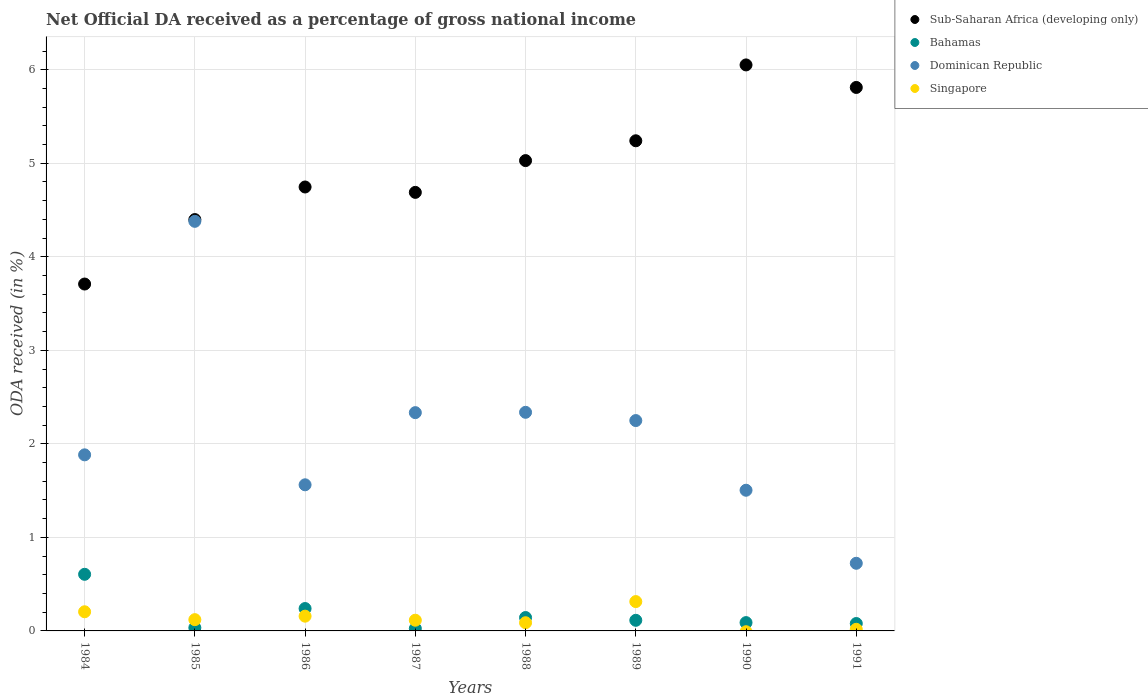How many different coloured dotlines are there?
Your response must be concise. 4. Is the number of dotlines equal to the number of legend labels?
Keep it short and to the point. No. What is the net official DA received in Bahamas in 1984?
Your response must be concise. 0.61. Across all years, what is the maximum net official DA received in Dominican Republic?
Provide a succinct answer. 4.38. Across all years, what is the minimum net official DA received in Bahamas?
Give a very brief answer. 0.03. What is the total net official DA received in Singapore in the graph?
Provide a short and direct response. 1.02. What is the difference between the net official DA received in Dominican Republic in 1987 and that in 1988?
Ensure brevity in your answer.  -0. What is the difference between the net official DA received in Singapore in 1984 and the net official DA received in Dominican Republic in 1989?
Provide a succinct answer. -2.04. What is the average net official DA received in Sub-Saharan Africa (developing only) per year?
Make the answer very short. 4.96. In the year 1988, what is the difference between the net official DA received in Bahamas and net official DA received in Dominican Republic?
Offer a very short reply. -2.19. What is the ratio of the net official DA received in Bahamas in 1986 to that in 1990?
Your answer should be compact. 2.69. Is the difference between the net official DA received in Bahamas in 1985 and 1991 greater than the difference between the net official DA received in Dominican Republic in 1985 and 1991?
Provide a succinct answer. No. What is the difference between the highest and the second highest net official DA received in Singapore?
Provide a succinct answer. 0.11. What is the difference between the highest and the lowest net official DA received in Bahamas?
Provide a succinct answer. 0.58. In how many years, is the net official DA received in Dominican Republic greater than the average net official DA received in Dominican Republic taken over all years?
Provide a short and direct response. 4. Is the sum of the net official DA received in Singapore in 1984 and 1988 greater than the maximum net official DA received in Sub-Saharan Africa (developing only) across all years?
Offer a terse response. No. Does the net official DA received in Sub-Saharan Africa (developing only) monotonically increase over the years?
Offer a terse response. No. Is the net official DA received in Sub-Saharan Africa (developing only) strictly less than the net official DA received in Dominican Republic over the years?
Keep it short and to the point. No. How many years are there in the graph?
Your answer should be very brief. 8. What is the difference between two consecutive major ticks on the Y-axis?
Your response must be concise. 1. Does the graph contain any zero values?
Make the answer very short. Yes. How many legend labels are there?
Provide a short and direct response. 4. How are the legend labels stacked?
Ensure brevity in your answer.  Vertical. What is the title of the graph?
Your answer should be very brief. Net Official DA received as a percentage of gross national income. What is the label or title of the Y-axis?
Keep it short and to the point. ODA received (in %). What is the ODA received (in %) in Sub-Saharan Africa (developing only) in 1984?
Ensure brevity in your answer.  3.71. What is the ODA received (in %) in Bahamas in 1984?
Your response must be concise. 0.61. What is the ODA received (in %) of Dominican Republic in 1984?
Your response must be concise. 1.88. What is the ODA received (in %) of Singapore in 1984?
Make the answer very short. 0.2. What is the ODA received (in %) of Sub-Saharan Africa (developing only) in 1985?
Your response must be concise. 4.4. What is the ODA received (in %) in Bahamas in 1985?
Keep it short and to the point. 0.03. What is the ODA received (in %) in Dominican Republic in 1985?
Make the answer very short. 4.38. What is the ODA received (in %) of Singapore in 1985?
Provide a short and direct response. 0.12. What is the ODA received (in %) of Sub-Saharan Africa (developing only) in 1986?
Make the answer very short. 4.75. What is the ODA received (in %) in Bahamas in 1986?
Your response must be concise. 0.24. What is the ODA received (in %) of Dominican Republic in 1986?
Offer a very short reply. 1.56. What is the ODA received (in %) of Singapore in 1986?
Ensure brevity in your answer.  0.16. What is the ODA received (in %) in Sub-Saharan Africa (developing only) in 1987?
Ensure brevity in your answer.  4.69. What is the ODA received (in %) of Bahamas in 1987?
Your answer should be compact. 0.03. What is the ODA received (in %) in Dominican Republic in 1987?
Make the answer very short. 2.33. What is the ODA received (in %) in Singapore in 1987?
Provide a succinct answer. 0.11. What is the ODA received (in %) in Sub-Saharan Africa (developing only) in 1988?
Your response must be concise. 5.03. What is the ODA received (in %) of Bahamas in 1988?
Provide a short and direct response. 0.14. What is the ODA received (in %) in Dominican Republic in 1988?
Keep it short and to the point. 2.34. What is the ODA received (in %) of Singapore in 1988?
Provide a short and direct response. 0.09. What is the ODA received (in %) of Sub-Saharan Africa (developing only) in 1989?
Ensure brevity in your answer.  5.24. What is the ODA received (in %) in Bahamas in 1989?
Your answer should be compact. 0.11. What is the ODA received (in %) in Dominican Republic in 1989?
Provide a short and direct response. 2.25. What is the ODA received (in %) of Singapore in 1989?
Make the answer very short. 0.31. What is the ODA received (in %) of Sub-Saharan Africa (developing only) in 1990?
Make the answer very short. 6.05. What is the ODA received (in %) in Bahamas in 1990?
Make the answer very short. 0.09. What is the ODA received (in %) of Dominican Republic in 1990?
Make the answer very short. 1.5. What is the ODA received (in %) in Sub-Saharan Africa (developing only) in 1991?
Make the answer very short. 5.81. What is the ODA received (in %) in Bahamas in 1991?
Offer a very short reply. 0.08. What is the ODA received (in %) in Dominican Republic in 1991?
Provide a succinct answer. 0.72. What is the ODA received (in %) of Singapore in 1991?
Provide a short and direct response. 0.02. Across all years, what is the maximum ODA received (in %) in Sub-Saharan Africa (developing only)?
Offer a very short reply. 6.05. Across all years, what is the maximum ODA received (in %) of Bahamas?
Offer a terse response. 0.61. Across all years, what is the maximum ODA received (in %) in Dominican Republic?
Give a very brief answer. 4.38. Across all years, what is the maximum ODA received (in %) in Singapore?
Offer a very short reply. 0.31. Across all years, what is the minimum ODA received (in %) in Sub-Saharan Africa (developing only)?
Ensure brevity in your answer.  3.71. Across all years, what is the minimum ODA received (in %) in Bahamas?
Your response must be concise. 0.03. Across all years, what is the minimum ODA received (in %) in Dominican Republic?
Your answer should be very brief. 0.72. Across all years, what is the minimum ODA received (in %) in Singapore?
Ensure brevity in your answer.  0. What is the total ODA received (in %) of Sub-Saharan Africa (developing only) in the graph?
Your response must be concise. 39.67. What is the total ODA received (in %) of Bahamas in the graph?
Offer a terse response. 1.33. What is the total ODA received (in %) in Dominican Republic in the graph?
Your answer should be very brief. 16.97. What is the total ODA received (in %) of Singapore in the graph?
Offer a terse response. 1.02. What is the difference between the ODA received (in %) of Sub-Saharan Africa (developing only) in 1984 and that in 1985?
Make the answer very short. -0.69. What is the difference between the ODA received (in %) in Bahamas in 1984 and that in 1985?
Your response must be concise. 0.57. What is the difference between the ODA received (in %) in Dominican Republic in 1984 and that in 1985?
Offer a very short reply. -2.5. What is the difference between the ODA received (in %) of Singapore in 1984 and that in 1985?
Make the answer very short. 0.08. What is the difference between the ODA received (in %) in Sub-Saharan Africa (developing only) in 1984 and that in 1986?
Offer a very short reply. -1.04. What is the difference between the ODA received (in %) of Bahamas in 1984 and that in 1986?
Your answer should be compact. 0.37. What is the difference between the ODA received (in %) in Dominican Republic in 1984 and that in 1986?
Your response must be concise. 0.32. What is the difference between the ODA received (in %) in Singapore in 1984 and that in 1986?
Provide a short and direct response. 0.05. What is the difference between the ODA received (in %) in Sub-Saharan Africa (developing only) in 1984 and that in 1987?
Provide a short and direct response. -0.98. What is the difference between the ODA received (in %) in Bahamas in 1984 and that in 1987?
Your answer should be compact. 0.58. What is the difference between the ODA received (in %) of Dominican Republic in 1984 and that in 1987?
Your answer should be very brief. -0.45. What is the difference between the ODA received (in %) of Singapore in 1984 and that in 1987?
Provide a short and direct response. 0.09. What is the difference between the ODA received (in %) in Sub-Saharan Africa (developing only) in 1984 and that in 1988?
Your answer should be very brief. -1.32. What is the difference between the ODA received (in %) of Bahamas in 1984 and that in 1988?
Ensure brevity in your answer.  0.46. What is the difference between the ODA received (in %) of Dominican Republic in 1984 and that in 1988?
Keep it short and to the point. -0.45. What is the difference between the ODA received (in %) in Singapore in 1984 and that in 1988?
Your response must be concise. 0.12. What is the difference between the ODA received (in %) of Sub-Saharan Africa (developing only) in 1984 and that in 1989?
Offer a terse response. -1.53. What is the difference between the ODA received (in %) of Bahamas in 1984 and that in 1989?
Ensure brevity in your answer.  0.49. What is the difference between the ODA received (in %) in Dominican Republic in 1984 and that in 1989?
Give a very brief answer. -0.37. What is the difference between the ODA received (in %) of Singapore in 1984 and that in 1989?
Offer a terse response. -0.11. What is the difference between the ODA received (in %) of Sub-Saharan Africa (developing only) in 1984 and that in 1990?
Ensure brevity in your answer.  -2.34. What is the difference between the ODA received (in %) of Bahamas in 1984 and that in 1990?
Provide a short and direct response. 0.52. What is the difference between the ODA received (in %) of Dominican Republic in 1984 and that in 1990?
Your answer should be very brief. 0.38. What is the difference between the ODA received (in %) in Sub-Saharan Africa (developing only) in 1984 and that in 1991?
Your response must be concise. -2.1. What is the difference between the ODA received (in %) of Bahamas in 1984 and that in 1991?
Your response must be concise. 0.53. What is the difference between the ODA received (in %) of Dominican Republic in 1984 and that in 1991?
Ensure brevity in your answer.  1.16. What is the difference between the ODA received (in %) of Singapore in 1984 and that in 1991?
Provide a succinct answer. 0.19. What is the difference between the ODA received (in %) of Sub-Saharan Africa (developing only) in 1985 and that in 1986?
Keep it short and to the point. -0.35. What is the difference between the ODA received (in %) in Bahamas in 1985 and that in 1986?
Make the answer very short. -0.21. What is the difference between the ODA received (in %) in Dominican Republic in 1985 and that in 1986?
Your response must be concise. 2.82. What is the difference between the ODA received (in %) of Singapore in 1985 and that in 1986?
Give a very brief answer. -0.04. What is the difference between the ODA received (in %) in Sub-Saharan Africa (developing only) in 1985 and that in 1987?
Provide a succinct answer. -0.29. What is the difference between the ODA received (in %) in Bahamas in 1985 and that in 1987?
Provide a short and direct response. 0.01. What is the difference between the ODA received (in %) of Dominican Republic in 1985 and that in 1987?
Your answer should be very brief. 2.05. What is the difference between the ODA received (in %) of Singapore in 1985 and that in 1987?
Offer a terse response. 0.01. What is the difference between the ODA received (in %) of Sub-Saharan Africa (developing only) in 1985 and that in 1988?
Give a very brief answer. -0.63. What is the difference between the ODA received (in %) in Bahamas in 1985 and that in 1988?
Your response must be concise. -0.11. What is the difference between the ODA received (in %) of Dominican Republic in 1985 and that in 1988?
Provide a succinct answer. 2.04. What is the difference between the ODA received (in %) of Singapore in 1985 and that in 1988?
Your answer should be compact. 0.03. What is the difference between the ODA received (in %) in Sub-Saharan Africa (developing only) in 1985 and that in 1989?
Ensure brevity in your answer.  -0.84. What is the difference between the ODA received (in %) in Bahamas in 1985 and that in 1989?
Give a very brief answer. -0.08. What is the difference between the ODA received (in %) in Dominican Republic in 1985 and that in 1989?
Make the answer very short. 2.13. What is the difference between the ODA received (in %) of Singapore in 1985 and that in 1989?
Ensure brevity in your answer.  -0.19. What is the difference between the ODA received (in %) of Sub-Saharan Africa (developing only) in 1985 and that in 1990?
Your response must be concise. -1.65. What is the difference between the ODA received (in %) of Bahamas in 1985 and that in 1990?
Keep it short and to the point. -0.06. What is the difference between the ODA received (in %) in Dominican Republic in 1985 and that in 1990?
Give a very brief answer. 2.87. What is the difference between the ODA received (in %) in Sub-Saharan Africa (developing only) in 1985 and that in 1991?
Your response must be concise. -1.41. What is the difference between the ODA received (in %) in Bahamas in 1985 and that in 1991?
Offer a very short reply. -0.05. What is the difference between the ODA received (in %) of Dominican Republic in 1985 and that in 1991?
Keep it short and to the point. 3.66. What is the difference between the ODA received (in %) in Singapore in 1985 and that in 1991?
Your response must be concise. 0.1. What is the difference between the ODA received (in %) in Sub-Saharan Africa (developing only) in 1986 and that in 1987?
Offer a terse response. 0.06. What is the difference between the ODA received (in %) in Bahamas in 1986 and that in 1987?
Your response must be concise. 0.21. What is the difference between the ODA received (in %) of Dominican Republic in 1986 and that in 1987?
Offer a very short reply. -0.77. What is the difference between the ODA received (in %) in Singapore in 1986 and that in 1987?
Provide a succinct answer. 0.04. What is the difference between the ODA received (in %) of Sub-Saharan Africa (developing only) in 1986 and that in 1988?
Provide a short and direct response. -0.28. What is the difference between the ODA received (in %) of Bahamas in 1986 and that in 1988?
Keep it short and to the point. 0.1. What is the difference between the ODA received (in %) in Dominican Republic in 1986 and that in 1988?
Provide a short and direct response. -0.78. What is the difference between the ODA received (in %) in Singapore in 1986 and that in 1988?
Ensure brevity in your answer.  0.07. What is the difference between the ODA received (in %) of Sub-Saharan Africa (developing only) in 1986 and that in 1989?
Your answer should be compact. -0.49. What is the difference between the ODA received (in %) in Bahamas in 1986 and that in 1989?
Provide a succinct answer. 0.13. What is the difference between the ODA received (in %) in Dominican Republic in 1986 and that in 1989?
Provide a succinct answer. -0.69. What is the difference between the ODA received (in %) in Singapore in 1986 and that in 1989?
Your answer should be very brief. -0.16. What is the difference between the ODA received (in %) in Sub-Saharan Africa (developing only) in 1986 and that in 1990?
Make the answer very short. -1.31. What is the difference between the ODA received (in %) in Bahamas in 1986 and that in 1990?
Ensure brevity in your answer.  0.15. What is the difference between the ODA received (in %) in Dominican Republic in 1986 and that in 1990?
Ensure brevity in your answer.  0.06. What is the difference between the ODA received (in %) in Sub-Saharan Africa (developing only) in 1986 and that in 1991?
Your answer should be very brief. -1.06. What is the difference between the ODA received (in %) of Bahamas in 1986 and that in 1991?
Provide a succinct answer. 0.16. What is the difference between the ODA received (in %) of Dominican Republic in 1986 and that in 1991?
Make the answer very short. 0.84. What is the difference between the ODA received (in %) of Singapore in 1986 and that in 1991?
Keep it short and to the point. 0.14. What is the difference between the ODA received (in %) in Sub-Saharan Africa (developing only) in 1987 and that in 1988?
Provide a short and direct response. -0.34. What is the difference between the ODA received (in %) of Bahamas in 1987 and that in 1988?
Your answer should be compact. -0.12. What is the difference between the ODA received (in %) in Dominican Republic in 1987 and that in 1988?
Keep it short and to the point. -0. What is the difference between the ODA received (in %) in Singapore in 1987 and that in 1988?
Give a very brief answer. 0.03. What is the difference between the ODA received (in %) in Sub-Saharan Africa (developing only) in 1987 and that in 1989?
Your answer should be compact. -0.55. What is the difference between the ODA received (in %) of Bahamas in 1987 and that in 1989?
Ensure brevity in your answer.  -0.09. What is the difference between the ODA received (in %) of Dominican Republic in 1987 and that in 1989?
Your answer should be compact. 0.08. What is the difference between the ODA received (in %) in Singapore in 1987 and that in 1989?
Your response must be concise. -0.2. What is the difference between the ODA received (in %) of Sub-Saharan Africa (developing only) in 1987 and that in 1990?
Your answer should be compact. -1.36. What is the difference between the ODA received (in %) of Bahamas in 1987 and that in 1990?
Provide a short and direct response. -0.06. What is the difference between the ODA received (in %) of Dominican Republic in 1987 and that in 1990?
Give a very brief answer. 0.83. What is the difference between the ODA received (in %) of Sub-Saharan Africa (developing only) in 1987 and that in 1991?
Keep it short and to the point. -1.12. What is the difference between the ODA received (in %) of Bahamas in 1987 and that in 1991?
Your response must be concise. -0.05. What is the difference between the ODA received (in %) in Dominican Republic in 1987 and that in 1991?
Your answer should be compact. 1.61. What is the difference between the ODA received (in %) of Singapore in 1987 and that in 1991?
Offer a terse response. 0.1. What is the difference between the ODA received (in %) in Sub-Saharan Africa (developing only) in 1988 and that in 1989?
Keep it short and to the point. -0.21. What is the difference between the ODA received (in %) of Bahamas in 1988 and that in 1989?
Offer a very short reply. 0.03. What is the difference between the ODA received (in %) of Dominican Republic in 1988 and that in 1989?
Offer a terse response. 0.09. What is the difference between the ODA received (in %) in Singapore in 1988 and that in 1989?
Provide a short and direct response. -0.23. What is the difference between the ODA received (in %) of Sub-Saharan Africa (developing only) in 1988 and that in 1990?
Your answer should be compact. -1.02. What is the difference between the ODA received (in %) of Bahamas in 1988 and that in 1990?
Your response must be concise. 0.05. What is the difference between the ODA received (in %) in Dominican Republic in 1988 and that in 1990?
Keep it short and to the point. 0.83. What is the difference between the ODA received (in %) of Sub-Saharan Africa (developing only) in 1988 and that in 1991?
Your response must be concise. -0.78. What is the difference between the ODA received (in %) in Bahamas in 1988 and that in 1991?
Give a very brief answer. 0.06. What is the difference between the ODA received (in %) in Dominican Republic in 1988 and that in 1991?
Provide a succinct answer. 1.61. What is the difference between the ODA received (in %) of Singapore in 1988 and that in 1991?
Your answer should be very brief. 0.07. What is the difference between the ODA received (in %) in Sub-Saharan Africa (developing only) in 1989 and that in 1990?
Give a very brief answer. -0.81. What is the difference between the ODA received (in %) of Bahamas in 1989 and that in 1990?
Provide a succinct answer. 0.02. What is the difference between the ODA received (in %) in Dominican Republic in 1989 and that in 1990?
Offer a terse response. 0.74. What is the difference between the ODA received (in %) of Sub-Saharan Africa (developing only) in 1989 and that in 1991?
Give a very brief answer. -0.57. What is the difference between the ODA received (in %) in Bahamas in 1989 and that in 1991?
Give a very brief answer. 0.03. What is the difference between the ODA received (in %) of Dominican Republic in 1989 and that in 1991?
Offer a very short reply. 1.53. What is the difference between the ODA received (in %) of Singapore in 1989 and that in 1991?
Your response must be concise. 0.3. What is the difference between the ODA received (in %) in Sub-Saharan Africa (developing only) in 1990 and that in 1991?
Offer a terse response. 0.24. What is the difference between the ODA received (in %) of Bahamas in 1990 and that in 1991?
Provide a succinct answer. 0.01. What is the difference between the ODA received (in %) in Dominican Republic in 1990 and that in 1991?
Ensure brevity in your answer.  0.78. What is the difference between the ODA received (in %) of Sub-Saharan Africa (developing only) in 1984 and the ODA received (in %) of Bahamas in 1985?
Provide a short and direct response. 3.67. What is the difference between the ODA received (in %) in Sub-Saharan Africa (developing only) in 1984 and the ODA received (in %) in Dominican Republic in 1985?
Keep it short and to the point. -0.67. What is the difference between the ODA received (in %) in Sub-Saharan Africa (developing only) in 1984 and the ODA received (in %) in Singapore in 1985?
Provide a short and direct response. 3.59. What is the difference between the ODA received (in %) of Bahamas in 1984 and the ODA received (in %) of Dominican Republic in 1985?
Keep it short and to the point. -3.77. What is the difference between the ODA received (in %) of Bahamas in 1984 and the ODA received (in %) of Singapore in 1985?
Ensure brevity in your answer.  0.48. What is the difference between the ODA received (in %) of Dominican Republic in 1984 and the ODA received (in %) of Singapore in 1985?
Your answer should be compact. 1.76. What is the difference between the ODA received (in %) in Sub-Saharan Africa (developing only) in 1984 and the ODA received (in %) in Bahamas in 1986?
Ensure brevity in your answer.  3.47. What is the difference between the ODA received (in %) of Sub-Saharan Africa (developing only) in 1984 and the ODA received (in %) of Dominican Republic in 1986?
Offer a terse response. 2.15. What is the difference between the ODA received (in %) of Sub-Saharan Africa (developing only) in 1984 and the ODA received (in %) of Singapore in 1986?
Keep it short and to the point. 3.55. What is the difference between the ODA received (in %) in Bahamas in 1984 and the ODA received (in %) in Dominican Republic in 1986?
Make the answer very short. -0.96. What is the difference between the ODA received (in %) in Bahamas in 1984 and the ODA received (in %) in Singapore in 1986?
Provide a succinct answer. 0.45. What is the difference between the ODA received (in %) of Dominican Republic in 1984 and the ODA received (in %) of Singapore in 1986?
Your answer should be very brief. 1.72. What is the difference between the ODA received (in %) of Sub-Saharan Africa (developing only) in 1984 and the ODA received (in %) of Bahamas in 1987?
Your answer should be compact. 3.68. What is the difference between the ODA received (in %) in Sub-Saharan Africa (developing only) in 1984 and the ODA received (in %) in Dominican Republic in 1987?
Offer a terse response. 1.38. What is the difference between the ODA received (in %) of Sub-Saharan Africa (developing only) in 1984 and the ODA received (in %) of Singapore in 1987?
Keep it short and to the point. 3.59. What is the difference between the ODA received (in %) of Bahamas in 1984 and the ODA received (in %) of Dominican Republic in 1987?
Make the answer very short. -1.73. What is the difference between the ODA received (in %) in Bahamas in 1984 and the ODA received (in %) in Singapore in 1987?
Provide a succinct answer. 0.49. What is the difference between the ODA received (in %) of Dominican Republic in 1984 and the ODA received (in %) of Singapore in 1987?
Your response must be concise. 1.77. What is the difference between the ODA received (in %) in Sub-Saharan Africa (developing only) in 1984 and the ODA received (in %) in Bahamas in 1988?
Your response must be concise. 3.57. What is the difference between the ODA received (in %) in Sub-Saharan Africa (developing only) in 1984 and the ODA received (in %) in Dominican Republic in 1988?
Your answer should be very brief. 1.37. What is the difference between the ODA received (in %) of Sub-Saharan Africa (developing only) in 1984 and the ODA received (in %) of Singapore in 1988?
Offer a terse response. 3.62. What is the difference between the ODA received (in %) in Bahamas in 1984 and the ODA received (in %) in Dominican Republic in 1988?
Make the answer very short. -1.73. What is the difference between the ODA received (in %) in Bahamas in 1984 and the ODA received (in %) in Singapore in 1988?
Your answer should be compact. 0.52. What is the difference between the ODA received (in %) in Dominican Republic in 1984 and the ODA received (in %) in Singapore in 1988?
Provide a short and direct response. 1.79. What is the difference between the ODA received (in %) in Sub-Saharan Africa (developing only) in 1984 and the ODA received (in %) in Bahamas in 1989?
Your answer should be very brief. 3.6. What is the difference between the ODA received (in %) in Sub-Saharan Africa (developing only) in 1984 and the ODA received (in %) in Dominican Republic in 1989?
Offer a terse response. 1.46. What is the difference between the ODA received (in %) of Sub-Saharan Africa (developing only) in 1984 and the ODA received (in %) of Singapore in 1989?
Provide a succinct answer. 3.4. What is the difference between the ODA received (in %) of Bahamas in 1984 and the ODA received (in %) of Dominican Republic in 1989?
Ensure brevity in your answer.  -1.64. What is the difference between the ODA received (in %) of Bahamas in 1984 and the ODA received (in %) of Singapore in 1989?
Provide a succinct answer. 0.29. What is the difference between the ODA received (in %) in Dominican Republic in 1984 and the ODA received (in %) in Singapore in 1989?
Your answer should be compact. 1.57. What is the difference between the ODA received (in %) in Sub-Saharan Africa (developing only) in 1984 and the ODA received (in %) in Bahamas in 1990?
Give a very brief answer. 3.62. What is the difference between the ODA received (in %) of Sub-Saharan Africa (developing only) in 1984 and the ODA received (in %) of Dominican Republic in 1990?
Provide a short and direct response. 2.2. What is the difference between the ODA received (in %) in Bahamas in 1984 and the ODA received (in %) in Dominican Republic in 1990?
Provide a short and direct response. -0.9. What is the difference between the ODA received (in %) in Sub-Saharan Africa (developing only) in 1984 and the ODA received (in %) in Bahamas in 1991?
Give a very brief answer. 3.63. What is the difference between the ODA received (in %) in Sub-Saharan Africa (developing only) in 1984 and the ODA received (in %) in Dominican Republic in 1991?
Offer a terse response. 2.99. What is the difference between the ODA received (in %) of Sub-Saharan Africa (developing only) in 1984 and the ODA received (in %) of Singapore in 1991?
Keep it short and to the point. 3.69. What is the difference between the ODA received (in %) of Bahamas in 1984 and the ODA received (in %) of Dominican Republic in 1991?
Your answer should be compact. -0.12. What is the difference between the ODA received (in %) in Bahamas in 1984 and the ODA received (in %) in Singapore in 1991?
Provide a short and direct response. 0.59. What is the difference between the ODA received (in %) of Dominican Republic in 1984 and the ODA received (in %) of Singapore in 1991?
Offer a terse response. 1.87. What is the difference between the ODA received (in %) of Sub-Saharan Africa (developing only) in 1985 and the ODA received (in %) of Bahamas in 1986?
Give a very brief answer. 4.16. What is the difference between the ODA received (in %) in Sub-Saharan Africa (developing only) in 1985 and the ODA received (in %) in Dominican Republic in 1986?
Provide a short and direct response. 2.84. What is the difference between the ODA received (in %) of Sub-Saharan Africa (developing only) in 1985 and the ODA received (in %) of Singapore in 1986?
Your answer should be compact. 4.24. What is the difference between the ODA received (in %) of Bahamas in 1985 and the ODA received (in %) of Dominican Republic in 1986?
Your answer should be compact. -1.53. What is the difference between the ODA received (in %) in Bahamas in 1985 and the ODA received (in %) in Singapore in 1986?
Offer a terse response. -0.12. What is the difference between the ODA received (in %) in Dominican Republic in 1985 and the ODA received (in %) in Singapore in 1986?
Keep it short and to the point. 4.22. What is the difference between the ODA received (in %) in Sub-Saharan Africa (developing only) in 1985 and the ODA received (in %) in Bahamas in 1987?
Offer a terse response. 4.37. What is the difference between the ODA received (in %) in Sub-Saharan Africa (developing only) in 1985 and the ODA received (in %) in Dominican Republic in 1987?
Provide a succinct answer. 2.06. What is the difference between the ODA received (in %) in Sub-Saharan Africa (developing only) in 1985 and the ODA received (in %) in Singapore in 1987?
Offer a very short reply. 4.28. What is the difference between the ODA received (in %) in Bahamas in 1985 and the ODA received (in %) in Dominican Republic in 1987?
Offer a very short reply. -2.3. What is the difference between the ODA received (in %) in Bahamas in 1985 and the ODA received (in %) in Singapore in 1987?
Provide a succinct answer. -0.08. What is the difference between the ODA received (in %) of Dominican Republic in 1985 and the ODA received (in %) of Singapore in 1987?
Offer a very short reply. 4.26. What is the difference between the ODA received (in %) of Sub-Saharan Africa (developing only) in 1985 and the ODA received (in %) of Bahamas in 1988?
Your answer should be compact. 4.25. What is the difference between the ODA received (in %) of Sub-Saharan Africa (developing only) in 1985 and the ODA received (in %) of Dominican Republic in 1988?
Offer a very short reply. 2.06. What is the difference between the ODA received (in %) in Sub-Saharan Africa (developing only) in 1985 and the ODA received (in %) in Singapore in 1988?
Your answer should be compact. 4.31. What is the difference between the ODA received (in %) of Bahamas in 1985 and the ODA received (in %) of Dominican Republic in 1988?
Ensure brevity in your answer.  -2.3. What is the difference between the ODA received (in %) in Bahamas in 1985 and the ODA received (in %) in Singapore in 1988?
Your response must be concise. -0.05. What is the difference between the ODA received (in %) of Dominican Republic in 1985 and the ODA received (in %) of Singapore in 1988?
Your answer should be compact. 4.29. What is the difference between the ODA received (in %) in Sub-Saharan Africa (developing only) in 1985 and the ODA received (in %) in Bahamas in 1989?
Keep it short and to the point. 4.28. What is the difference between the ODA received (in %) of Sub-Saharan Africa (developing only) in 1985 and the ODA received (in %) of Dominican Republic in 1989?
Offer a very short reply. 2.15. What is the difference between the ODA received (in %) in Sub-Saharan Africa (developing only) in 1985 and the ODA received (in %) in Singapore in 1989?
Provide a succinct answer. 4.08. What is the difference between the ODA received (in %) in Bahamas in 1985 and the ODA received (in %) in Dominican Republic in 1989?
Your response must be concise. -2.22. What is the difference between the ODA received (in %) of Bahamas in 1985 and the ODA received (in %) of Singapore in 1989?
Provide a succinct answer. -0.28. What is the difference between the ODA received (in %) in Dominican Republic in 1985 and the ODA received (in %) in Singapore in 1989?
Your response must be concise. 4.07. What is the difference between the ODA received (in %) of Sub-Saharan Africa (developing only) in 1985 and the ODA received (in %) of Bahamas in 1990?
Give a very brief answer. 4.31. What is the difference between the ODA received (in %) in Sub-Saharan Africa (developing only) in 1985 and the ODA received (in %) in Dominican Republic in 1990?
Your answer should be very brief. 2.89. What is the difference between the ODA received (in %) of Bahamas in 1985 and the ODA received (in %) of Dominican Republic in 1990?
Keep it short and to the point. -1.47. What is the difference between the ODA received (in %) in Sub-Saharan Africa (developing only) in 1985 and the ODA received (in %) in Bahamas in 1991?
Give a very brief answer. 4.32. What is the difference between the ODA received (in %) in Sub-Saharan Africa (developing only) in 1985 and the ODA received (in %) in Dominican Republic in 1991?
Offer a very short reply. 3.67. What is the difference between the ODA received (in %) of Sub-Saharan Africa (developing only) in 1985 and the ODA received (in %) of Singapore in 1991?
Offer a very short reply. 4.38. What is the difference between the ODA received (in %) of Bahamas in 1985 and the ODA received (in %) of Dominican Republic in 1991?
Your response must be concise. -0.69. What is the difference between the ODA received (in %) in Bahamas in 1985 and the ODA received (in %) in Singapore in 1991?
Offer a terse response. 0.02. What is the difference between the ODA received (in %) in Dominican Republic in 1985 and the ODA received (in %) in Singapore in 1991?
Your response must be concise. 4.36. What is the difference between the ODA received (in %) in Sub-Saharan Africa (developing only) in 1986 and the ODA received (in %) in Bahamas in 1987?
Provide a succinct answer. 4.72. What is the difference between the ODA received (in %) of Sub-Saharan Africa (developing only) in 1986 and the ODA received (in %) of Dominican Republic in 1987?
Make the answer very short. 2.41. What is the difference between the ODA received (in %) in Sub-Saharan Africa (developing only) in 1986 and the ODA received (in %) in Singapore in 1987?
Keep it short and to the point. 4.63. What is the difference between the ODA received (in %) of Bahamas in 1986 and the ODA received (in %) of Dominican Republic in 1987?
Give a very brief answer. -2.09. What is the difference between the ODA received (in %) in Bahamas in 1986 and the ODA received (in %) in Singapore in 1987?
Your response must be concise. 0.12. What is the difference between the ODA received (in %) in Dominican Republic in 1986 and the ODA received (in %) in Singapore in 1987?
Make the answer very short. 1.45. What is the difference between the ODA received (in %) of Sub-Saharan Africa (developing only) in 1986 and the ODA received (in %) of Bahamas in 1988?
Ensure brevity in your answer.  4.6. What is the difference between the ODA received (in %) in Sub-Saharan Africa (developing only) in 1986 and the ODA received (in %) in Dominican Republic in 1988?
Your answer should be compact. 2.41. What is the difference between the ODA received (in %) of Sub-Saharan Africa (developing only) in 1986 and the ODA received (in %) of Singapore in 1988?
Your answer should be very brief. 4.66. What is the difference between the ODA received (in %) in Bahamas in 1986 and the ODA received (in %) in Dominican Republic in 1988?
Provide a short and direct response. -2.1. What is the difference between the ODA received (in %) of Bahamas in 1986 and the ODA received (in %) of Singapore in 1988?
Offer a terse response. 0.15. What is the difference between the ODA received (in %) of Dominican Republic in 1986 and the ODA received (in %) of Singapore in 1988?
Make the answer very short. 1.47. What is the difference between the ODA received (in %) in Sub-Saharan Africa (developing only) in 1986 and the ODA received (in %) in Bahamas in 1989?
Give a very brief answer. 4.63. What is the difference between the ODA received (in %) of Sub-Saharan Africa (developing only) in 1986 and the ODA received (in %) of Dominican Republic in 1989?
Offer a very short reply. 2.5. What is the difference between the ODA received (in %) of Sub-Saharan Africa (developing only) in 1986 and the ODA received (in %) of Singapore in 1989?
Your answer should be compact. 4.43. What is the difference between the ODA received (in %) in Bahamas in 1986 and the ODA received (in %) in Dominican Republic in 1989?
Make the answer very short. -2.01. What is the difference between the ODA received (in %) of Bahamas in 1986 and the ODA received (in %) of Singapore in 1989?
Your answer should be compact. -0.07. What is the difference between the ODA received (in %) in Dominican Republic in 1986 and the ODA received (in %) in Singapore in 1989?
Keep it short and to the point. 1.25. What is the difference between the ODA received (in %) in Sub-Saharan Africa (developing only) in 1986 and the ODA received (in %) in Bahamas in 1990?
Your answer should be very brief. 4.66. What is the difference between the ODA received (in %) in Sub-Saharan Africa (developing only) in 1986 and the ODA received (in %) in Dominican Republic in 1990?
Give a very brief answer. 3.24. What is the difference between the ODA received (in %) of Bahamas in 1986 and the ODA received (in %) of Dominican Republic in 1990?
Your response must be concise. -1.26. What is the difference between the ODA received (in %) in Sub-Saharan Africa (developing only) in 1986 and the ODA received (in %) in Bahamas in 1991?
Offer a terse response. 4.67. What is the difference between the ODA received (in %) in Sub-Saharan Africa (developing only) in 1986 and the ODA received (in %) in Dominican Republic in 1991?
Your response must be concise. 4.02. What is the difference between the ODA received (in %) in Sub-Saharan Africa (developing only) in 1986 and the ODA received (in %) in Singapore in 1991?
Provide a succinct answer. 4.73. What is the difference between the ODA received (in %) in Bahamas in 1986 and the ODA received (in %) in Dominican Republic in 1991?
Your response must be concise. -0.48. What is the difference between the ODA received (in %) in Bahamas in 1986 and the ODA received (in %) in Singapore in 1991?
Provide a succinct answer. 0.22. What is the difference between the ODA received (in %) of Dominican Republic in 1986 and the ODA received (in %) of Singapore in 1991?
Your response must be concise. 1.54. What is the difference between the ODA received (in %) in Sub-Saharan Africa (developing only) in 1987 and the ODA received (in %) in Bahamas in 1988?
Your answer should be very brief. 4.55. What is the difference between the ODA received (in %) in Sub-Saharan Africa (developing only) in 1987 and the ODA received (in %) in Dominican Republic in 1988?
Your answer should be compact. 2.35. What is the difference between the ODA received (in %) in Sub-Saharan Africa (developing only) in 1987 and the ODA received (in %) in Singapore in 1988?
Your answer should be very brief. 4.6. What is the difference between the ODA received (in %) in Bahamas in 1987 and the ODA received (in %) in Dominican Republic in 1988?
Keep it short and to the point. -2.31. What is the difference between the ODA received (in %) of Bahamas in 1987 and the ODA received (in %) of Singapore in 1988?
Your answer should be very brief. -0.06. What is the difference between the ODA received (in %) of Dominican Republic in 1987 and the ODA received (in %) of Singapore in 1988?
Give a very brief answer. 2.25. What is the difference between the ODA received (in %) in Sub-Saharan Africa (developing only) in 1987 and the ODA received (in %) in Bahamas in 1989?
Offer a very short reply. 4.58. What is the difference between the ODA received (in %) of Sub-Saharan Africa (developing only) in 1987 and the ODA received (in %) of Dominican Republic in 1989?
Your answer should be compact. 2.44. What is the difference between the ODA received (in %) in Sub-Saharan Africa (developing only) in 1987 and the ODA received (in %) in Singapore in 1989?
Make the answer very short. 4.38. What is the difference between the ODA received (in %) in Bahamas in 1987 and the ODA received (in %) in Dominican Republic in 1989?
Your answer should be very brief. -2.22. What is the difference between the ODA received (in %) of Bahamas in 1987 and the ODA received (in %) of Singapore in 1989?
Your answer should be compact. -0.29. What is the difference between the ODA received (in %) in Dominican Republic in 1987 and the ODA received (in %) in Singapore in 1989?
Ensure brevity in your answer.  2.02. What is the difference between the ODA received (in %) in Sub-Saharan Africa (developing only) in 1987 and the ODA received (in %) in Bahamas in 1990?
Your answer should be compact. 4.6. What is the difference between the ODA received (in %) in Sub-Saharan Africa (developing only) in 1987 and the ODA received (in %) in Dominican Republic in 1990?
Your response must be concise. 3.18. What is the difference between the ODA received (in %) in Bahamas in 1987 and the ODA received (in %) in Dominican Republic in 1990?
Your response must be concise. -1.48. What is the difference between the ODA received (in %) of Sub-Saharan Africa (developing only) in 1987 and the ODA received (in %) of Bahamas in 1991?
Your answer should be very brief. 4.61. What is the difference between the ODA received (in %) in Sub-Saharan Africa (developing only) in 1987 and the ODA received (in %) in Dominican Republic in 1991?
Keep it short and to the point. 3.97. What is the difference between the ODA received (in %) of Sub-Saharan Africa (developing only) in 1987 and the ODA received (in %) of Singapore in 1991?
Your answer should be compact. 4.67. What is the difference between the ODA received (in %) of Bahamas in 1987 and the ODA received (in %) of Dominican Republic in 1991?
Offer a terse response. -0.7. What is the difference between the ODA received (in %) in Bahamas in 1987 and the ODA received (in %) in Singapore in 1991?
Your response must be concise. 0.01. What is the difference between the ODA received (in %) of Dominican Republic in 1987 and the ODA received (in %) of Singapore in 1991?
Make the answer very short. 2.32. What is the difference between the ODA received (in %) in Sub-Saharan Africa (developing only) in 1988 and the ODA received (in %) in Bahamas in 1989?
Your answer should be very brief. 4.92. What is the difference between the ODA received (in %) in Sub-Saharan Africa (developing only) in 1988 and the ODA received (in %) in Dominican Republic in 1989?
Provide a succinct answer. 2.78. What is the difference between the ODA received (in %) in Sub-Saharan Africa (developing only) in 1988 and the ODA received (in %) in Singapore in 1989?
Ensure brevity in your answer.  4.71. What is the difference between the ODA received (in %) of Bahamas in 1988 and the ODA received (in %) of Dominican Republic in 1989?
Ensure brevity in your answer.  -2.11. What is the difference between the ODA received (in %) of Bahamas in 1988 and the ODA received (in %) of Singapore in 1989?
Give a very brief answer. -0.17. What is the difference between the ODA received (in %) in Dominican Republic in 1988 and the ODA received (in %) in Singapore in 1989?
Offer a very short reply. 2.02. What is the difference between the ODA received (in %) of Sub-Saharan Africa (developing only) in 1988 and the ODA received (in %) of Bahamas in 1990?
Your response must be concise. 4.94. What is the difference between the ODA received (in %) of Sub-Saharan Africa (developing only) in 1988 and the ODA received (in %) of Dominican Republic in 1990?
Your answer should be compact. 3.52. What is the difference between the ODA received (in %) in Bahamas in 1988 and the ODA received (in %) in Dominican Republic in 1990?
Offer a very short reply. -1.36. What is the difference between the ODA received (in %) of Sub-Saharan Africa (developing only) in 1988 and the ODA received (in %) of Bahamas in 1991?
Your response must be concise. 4.95. What is the difference between the ODA received (in %) in Sub-Saharan Africa (developing only) in 1988 and the ODA received (in %) in Dominican Republic in 1991?
Offer a very short reply. 4.31. What is the difference between the ODA received (in %) in Sub-Saharan Africa (developing only) in 1988 and the ODA received (in %) in Singapore in 1991?
Keep it short and to the point. 5.01. What is the difference between the ODA received (in %) in Bahamas in 1988 and the ODA received (in %) in Dominican Republic in 1991?
Offer a very short reply. -0.58. What is the difference between the ODA received (in %) of Bahamas in 1988 and the ODA received (in %) of Singapore in 1991?
Provide a short and direct response. 0.13. What is the difference between the ODA received (in %) of Dominican Republic in 1988 and the ODA received (in %) of Singapore in 1991?
Offer a very short reply. 2.32. What is the difference between the ODA received (in %) in Sub-Saharan Africa (developing only) in 1989 and the ODA received (in %) in Bahamas in 1990?
Your answer should be compact. 5.15. What is the difference between the ODA received (in %) in Sub-Saharan Africa (developing only) in 1989 and the ODA received (in %) in Dominican Republic in 1990?
Provide a short and direct response. 3.74. What is the difference between the ODA received (in %) in Bahamas in 1989 and the ODA received (in %) in Dominican Republic in 1990?
Offer a very short reply. -1.39. What is the difference between the ODA received (in %) of Sub-Saharan Africa (developing only) in 1989 and the ODA received (in %) of Bahamas in 1991?
Give a very brief answer. 5.16. What is the difference between the ODA received (in %) of Sub-Saharan Africa (developing only) in 1989 and the ODA received (in %) of Dominican Republic in 1991?
Provide a short and direct response. 4.52. What is the difference between the ODA received (in %) in Sub-Saharan Africa (developing only) in 1989 and the ODA received (in %) in Singapore in 1991?
Offer a terse response. 5.22. What is the difference between the ODA received (in %) of Bahamas in 1989 and the ODA received (in %) of Dominican Republic in 1991?
Your answer should be compact. -0.61. What is the difference between the ODA received (in %) in Bahamas in 1989 and the ODA received (in %) in Singapore in 1991?
Your answer should be very brief. 0.1. What is the difference between the ODA received (in %) in Dominican Republic in 1989 and the ODA received (in %) in Singapore in 1991?
Ensure brevity in your answer.  2.23. What is the difference between the ODA received (in %) of Sub-Saharan Africa (developing only) in 1990 and the ODA received (in %) of Bahamas in 1991?
Make the answer very short. 5.97. What is the difference between the ODA received (in %) in Sub-Saharan Africa (developing only) in 1990 and the ODA received (in %) in Dominican Republic in 1991?
Provide a succinct answer. 5.33. What is the difference between the ODA received (in %) in Sub-Saharan Africa (developing only) in 1990 and the ODA received (in %) in Singapore in 1991?
Give a very brief answer. 6.03. What is the difference between the ODA received (in %) in Bahamas in 1990 and the ODA received (in %) in Dominican Republic in 1991?
Keep it short and to the point. -0.63. What is the difference between the ODA received (in %) of Bahamas in 1990 and the ODA received (in %) of Singapore in 1991?
Your answer should be very brief. 0.07. What is the difference between the ODA received (in %) in Dominican Republic in 1990 and the ODA received (in %) in Singapore in 1991?
Ensure brevity in your answer.  1.49. What is the average ODA received (in %) in Sub-Saharan Africa (developing only) per year?
Give a very brief answer. 4.96. What is the average ODA received (in %) in Bahamas per year?
Provide a succinct answer. 0.17. What is the average ODA received (in %) of Dominican Republic per year?
Your answer should be very brief. 2.12. What is the average ODA received (in %) of Singapore per year?
Your answer should be compact. 0.13. In the year 1984, what is the difference between the ODA received (in %) in Sub-Saharan Africa (developing only) and ODA received (in %) in Bahamas?
Offer a terse response. 3.1. In the year 1984, what is the difference between the ODA received (in %) in Sub-Saharan Africa (developing only) and ODA received (in %) in Dominican Republic?
Offer a terse response. 1.83. In the year 1984, what is the difference between the ODA received (in %) of Sub-Saharan Africa (developing only) and ODA received (in %) of Singapore?
Provide a succinct answer. 3.5. In the year 1984, what is the difference between the ODA received (in %) of Bahamas and ODA received (in %) of Dominican Republic?
Offer a terse response. -1.28. In the year 1984, what is the difference between the ODA received (in %) of Bahamas and ODA received (in %) of Singapore?
Provide a short and direct response. 0.4. In the year 1984, what is the difference between the ODA received (in %) in Dominican Republic and ODA received (in %) in Singapore?
Ensure brevity in your answer.  1.68. In the year 1985, what is the difference between the ODA received (in %) of Sub-Saharan Africa (developing only) and ODA received (in %) of Bahamas?
Your answer should be very brief. 4.36. In the year 1985, what is the difference between the ODA received (in %) in Sub-Saharan Africa (developing only) and ODA received (in %) in Dominican Republic?
Your answer should be very brief. 0.02. In the year 1985, what is the difference between the ODA received (in %) of Sub-Saharan Africa (developing only) and ODA received (in %) of Singapore?
Offer a terse response. 4.28. In the year 1985, what is the difference between the ODA received (in %) of Bahamas and ODA received (in %) of Dominican Republic?
Make the answer very short. -4.35. In the year 1985, what is the difference between the ODA received (in %) of Bahamas and ODA received (in %) of Singapore?
Provide a short and direct response. -0.09. In the year 1985, what is the difference between the ODA received (in %) of Dominican Republic and ODA received (in %) of Singapore?
Offer a terse response. 4.26. In the year 1986, what is the difference between the ODA received (in %) in Sub-Saharan Africa (developing only) and ODA received (in %) in Bahamas?
Keep it short and to the point. 4.51. In the year 1986, what is the difference between the ODA received (in %) in Sub-Saharan Africa (developing only) and ODA received (in %) in Dominican Republic?
Keep it short and to the point. 3.18. In the year 1986, what is the difference between the ODA received (in %) in Sub-Saharan Africa (developing only) and ODA received (in %) in Singapore?
Offer a very short reply. 4.59. In the year 1986, what is the difference between the ODA received (in %) in Bahamas and ODA received (in %) in Dominican Republic?
Provide a succinct answer. -1.32. In the year 1986, what is the difference between the ODA received (in %) in Bahamas and ODA received (in %) in Singapore?
Provide a short and direct response. 0.08. In the year 1986, what is the difference between the ODA received (in %) of Dominican Republic and ODA received (in %) of Singapore?
Provide a short and direct response. 1.4. In the year 1987, what is the difference between the ODA received (in %) in Sub-Saharan Africa (developing only) and ODA received (in %) in Bahamas?
Provide a succinct answer. 4.66. In the year 1987, what is the difference between the ODA received (in %) in Sub-Saharan Africa (developing only) and ODA received (in %) in Dominican Republic?
Ensure brevity in your answer.  2.35. In the year 1987, what is the difference between the ODA received (in %) of Sub-Saharan Africa (developing only) and ODA received (in %) of Singapore?
Provide a succinct answer. 4.57. In the year 1987, what is the difference between the ODA received (in %) of Bahamas and ODA received (in %) of Dominican Republic?
Make the answer very short. -2.31. In the year 1987, what is the difference between the ODA received (in %) in Bahamas and ODA received (in %) in Singapore?
Your response must be concise. -0.09. In the year 1987, what is the difference between the ODA received (in %) in Dominican Republic and ODA received (in %) in Singapore?
Your response must be concise. 2.22. In the year 1988, what is the difference between the ODA received (in %) in Sub-Saharan Africa (developing only) and ODA received (in %) in Bahamas?
Offer a terse response. 4.89. In the year 1988, what is the difference between the ODA received (in %) in Sub-Saharan Africa (developing only) and ODA received (in %) in Dominican Republic?
Make the answer very short. 2.69. In the year 1988, what is the difference between the ODA received (in %) in Sub-Saharan Africa (developing only) and ODA received (in %) in Singapore?
Make the answer very short. 4.94. In the year 1988, what is the difference between the ODA received (in %) in Bahamas and ODA received (in %) in Dominican Republic?
Provide a short and direct response. -2.19. In the year 1988, what is the difference between the ODA received (in %) of Bahamas and ODA received (in %) of Singapore?
Your answer should be compact. 0.06. In the year 1988, what is the difference between the ODA received (in %) of Dominican Republic and ODA received (in %) of Singapore?
Give a very brief answer. 2.25. In the year 1989, what is the difference between the ODA received (in %) in Sub-Saharan Africa (developing only) and ODA received (in %) in Bahamas?
Your answer should be very brief. 5.13. In the year 1989, what is the difference between the ODA received (in %) of Sub-Saharan Africa (developing only) and ODA received (in %) of Dominican Republic?
Keep it short and to the point. 2.99. In the year 1989, what is the difference between the ODA received (in %) of Sub-Saharan Africa (developing only) and ODA received (in %) of Singapore?
Offer a very short reply. 4.93. In the year 1989, what is the difference between the ODA received (in %) in Bahamas and ODA received (in %) in Dominican Republic?
Give a very brief answer. -2.14. In the year 1989, what is the difference between the ODA received (in %) of Bahamas and ODA received (in %) of Singapore?
Keep it short and to the point. -0.2. In the year 1989, what is the difference between the ODA received (in %) in Dominican Republic and ODA received (in %) in Singapore?
Offer a terse response. 1.94. In the year 1990, what is the difference between the ODA received (in %) of Sub-Saharan Africa (developing only) and ODA received (in %) of Bahamas?
Keep it short and to the point. 5.96. In the year 1990, what is the difference between the ODA received (in %) of Sub-Saharan Africa (developing only) and ODA received (in %) of Dominican Republic?
Your answer should be very brief. 4.55. In the year 1990, what is the difference between the ODA received (in %) in Bahamas and ODA received (in %) in Dominican Republic?
Keep it short and to the point. -1.42. In the year 1991, what is the difference between the ODA received (in %) of Sub-Saharan Africa (developing only) and ODA received (in %) of Bahamas?
Offer a very short reply. 5.73. In the year 1991, what is the difference between the ODA received (in %) in Sub-Saharan Africa (developing only) and ODA received (in %) in Dominican Republic?
Your answer should be compact. 5.09. In the year 1991, what is the difference between the ODA received (in %) of Sub-Saharan Africa (developing only) and ODA received (in %) of Singapore?
Keep it short and to the point. 5.79. In the year 1991, what is the difference between the ODA received (in %) of Bahamas and ODA received (in %) of Dominican Republic?
Provide a short and direct response. -0.64. In the year 1991, what is the difference between the ODA received (in %) of Bahamas and ODA received (in %) of Singapore?
Make the answer very short. 0.06. In the year 1991, what is the difference between the ODA received (in %) in Dominican Republic and ODA received (in %) in Singapore?
Ensure brevity in your answer.  0.71. What is the ratio of the ODA received (in %) of Sub-Saharan Africa (developing only) in 1984 to that in 1985?
Keep it short and to the point. 0.84. What is the ratio of the ODA received (in %) of Bahamas in 1984 to that in 1985?
Offer a terse response. 17.86. What is the ratio of the ODA received (in %) in Dominican Republic in 1984 to that in 1985?
Keep it short and to the point. 0.43. What is the ratio of the ODA received (in %) in Singapore in 1984 to that in 1985?
Make the answer very short. 1.7. What is the ratio of the ODA received (in %) in Sub-Saharan Africa (developing only) in 1984 to that in 1986?
Your response must be concise. 0.78. What is the ratio of the ODA received (in %) in Bahamas in 1984 to that in 1986?
Offer a terse response. 2.53. What is the ratio of the ODA received (in %) in Dominican Republic in 1984 to that in 1986?
Give a very brief answer. 1.21. What is the ratio of the ODA received (in %) of Singapore in 1984 to that in 1986?
Provide a succinct answer. 1.3. What is the ratio of the ODA received (in %) in Sub-Saharan Africa (developing only) in 1984 to that in 1987?
Provide a succinct answer. 0.79. What is the ratio of the ODA received (in %) of Bahamas in 1984 to that in 1987?
Give a very brief answer. 23.69. What is the ratio of the ODA received (in %) of Dominican Republic in 1984 to that in 1987?
Your answer should be compact. 0.81. What is the ratio of the ODA received (in %) of Singapore in 1984 to that in 1987?
Provide a short and direct response. 1.79. What is the ratio of the ODA received (in %) of Sub-Saharan Africa (developing only) in 1984 to that in 1988?
Provide a succinct answer. 0.74. What is the ratio of the ODA received (in %) of Bahamas in 1984 to that in 1988?
Give a very brief answer. 4.23. What is the ratio of the ODA received (in %) in Dominican Republic in 1984 to that in 1988?
Give a very brief answer. 0.81. What is the ratio of the ODA received (in %) of Singapore in 1984 to that in 1988?
Make the answer very short. 2.34. What is the ratio of the ODA received (in %) of Sub-Saharan Africa (developing only) in 1984 to that in 1989?
Make the answer very short. 0.71. What is the ratio of the ODA received (in %) in Bahamas in 1984 to that in 1989?
Keep it short and to the point. 5.34. What is the ratio of the ODA received (in %) in Dominican Republic in 1984 to that in 1989?
Offer a very short reply. 0.84. What is the ratio of the ODA received (in %) of Singapore in 1984 to that in 1989?
Offer a terse response. 0.65. What is the ratio of the ODA received (in %) of Sub-Saharan Africa (developing only) in 1984 to that in 1990?
Offer a very short reply. 0.61. What is the ratio of the ODA received (in %) of Bahamas in 1984 to that in 1990?
Your answer should be very brief. 6.81. What is the ratio of the ODA received (in %) in Dominican Republic in 1984 to that in 1990?
Keep it short and to the point. 1.25. What is the ratio of the ODA received (in %) in Sub-Saharan Africa (developing only) in 1984 to that in 1991?
Offer a very short reply. 0.64. What is the ratio of the ODA received (in %) in Bahamas in 1984 to that in 1991?
Provide a short and direct response. 7.65. What is the ratio of the ODA received (in %) of Dominican Republic in 1984 to that in 1991?
Provide a short and direct response. 2.6. What is the ratio of the ODA received (in %) of Singapore in 1984 to that in 1991?
Ensure brevity in your answer.  11.8. What is the ratio of the ODA received (in %) in Sub-Saharan Africa (developing only) in 1985 to that in 1986?
Offer a terse response. 0.93. What is the ratio of the ODA received (in %) in Bahamas in 1985 to that in 1986?
Give a very brief answer. 0.14. What is the ratio of the ODA received (in %) of Dominican Republic in 1985 to that in 1986?
Give a very brief answer. 2.8. What is the ratio of the ODA received (in %) in Singapore in 1985 to that in 1986?
Offer a very short reply. 0.76. What is the ratio of the ODA received (in %) of Sub-Saharan Africa (developing only) in 1985 to that in 1987?
Give a very brief answer. 0.94. What is the ratio of the ODA received (in %) of Bahamas in 1985 to that in 1987?
Give a very brief answer. 1.33. What is the ratio of the ODA received (in %) in Dominican Republic in 1985 to that in 1987?
Give a very brief answer. 1.88. What is the ratio of the ODA received (in %) in Singapore in 1985 to that in 1987?
Offer a terse response. 1.05. What is the ratio of the ODA received (in %) of Sub-Saharan Africa (developing only) in 1985 to that in 1988?
Keep it short and to the point. 0.87. What is the ratio of the ODA received (in %) of Bahamas in 1985 to that in 1988?
Provide a succinct answer. 0.24. What is the ratio of the ODA received (in %) of Dominican Republic in 1985 to that in 1988?
Provide a short and direct response. 1.87. What is the ratio of the ODA received (in %) of Singapore in 1985 to that in 1988?
Make the answer very short. 1.38. What is the ratio of the ODA received (in %) of Sub-Saharan Africa (developing only) in 1985 to that in 1989?
Your answer should be very brief. 0.84. What is the ratio of the ODA received (in %) in Bahamas in 1985 to that in 1989?
Your answer should be very brief. 0.3. What is the ratio of the ODA received (in %) of Dominican Republic in 1985 to that in 1989?
Keep it short and to the point. 1.95. What is the ratio of the ODA received (in %) of Singapore in 1985 to that in 1989?
Your response must be concise. 0.38. What is the ratio of the ODA received (in %) of Sub-Saharan Africa (developing only) in 1985 to that in 1990?
Provide a succinct answer. 0.73. What is the ratio of the ODA received (in %) in Bahamas in 1985 to that in 1990?
Provide a succinct answer. 0.38. What is the ratio of the ODA received (in %) in Dominican Republic in 1985 to that in 1990?
Your answer should be compact. 2.91. What is the ratio of the ODA received (in %) of Sub-Saharan Africa (developing only) in 1985 to that in 1991?
Your response must be concise. 0.76. What is the ratio of the ODA received (in %) of Bahamas in 1985 to that in 1991?
Provide a short and direct response. 0.43. What is the ratio of the ODA received (in %) of Dominican Republic in 1985 to that in 1991?
Your answer should be compact. 6.06. What is the ratio of the ODA received (in %) in Singapore in 1985 to that in 1991?
Ensure brevity in your answer.  6.95. What is the ratio of the ODA received (in %) of Sub-Saharan Africa (developing only) in 1986 to that in 1987?
Offer a very short reply. 1.01. What is the ratio of the ODA received (in %) of Bahamas in 1986 to that in 1987?
Give a very brief answer. 9.36. What is the ratio of the ODA received (in %) in Dominican Republic in 1986 to that in 1987?
Make the answer very short. 0.67. What is the ratio of the ODA received (in %) of Singapore in 1986 to that in 1987?
Keep it short and to the point. 1.38. What is the ratio of the ODA received (in %) in Sub-Saharan Africa (developing only) in 1986 to that in 1988?
Provide a succinct answer. 0.94. What is the ratio of the ODA received (in %) of Bahamas in 1986 to that in 1988?
Keep it short and to the point. 1.67. What is the ratio of the ODA received (in %) in Dominican Republic in 1986 to that in 1988?
Your answer should be compact. 0.67. What is the ratio of the ODA received (in %) in Singapore in 1986 to that in 1988?
Your answer should be compact. 1.8. What is the ratio of the ODA received (in %) of Sub-Saharan Africa (developing only) in 1986 to that in 1989?
Offer a terse response. 0.91. What is the ratio of the ODA received (in %) of Bahamas in 1986 to that in 1989?
Your response must be concise. 2.11. What is the ratio of the ODA received (in %) in Dominican Republic in 1986 to that in 1989?
Make the answer very short. 0.69. What is the ratio of the ODA received (in %) in Singapore in 1986 to that in 1989?
Make the answer very short. 0.5. What is the ratio of the ODA received (in %) in Sub-Saharan Africa (developing only) in 1986 to that in 1990?
Provide a succinct answer. 0.78. What is the ratio of the ODA received (in %) of Bahamas in 1986 to that in 1990?
Your answer should be very brief. 2.69. What is the ratio of the ODA received (in %) of Dominican Republic in 1986 to that in 1990?
Give a very brief answer. 1.04. What is the ratio of the ODA received (in %) in Sub-Saharan Africa (developing only) in 1986 to that in 1991?
Offer a very short reply. 0.82. What is the ratio of the ODA received (in %) in Bahamas in 1986 to that in 1991?
Provide a succinct answer. 3.02. What is the ratio of the ODA received (in %) in Dominican Republic in 1986 to that in 1991?
Offer a very short reply. 2.16. What is the ratio of the ODA received (in %) of Singapore in 1986 to that in 1991?
Offer a very short reply. 9.09. What is the ratio of the ODA received (in %) in Sub-Saharan Africa (developing only) in 1987 to that in 1988?
Offer a very short reply. 0.93. What is the ratio of the ODA received (in %) of Bahamas in 1987 to that in 1988?
Your response must be concise. 0.18. What is the ratio of the ODA received (in %) in Dominican Republic in 1987 to that in 1988?
Offer a very short reply. 1. What is the ratio of the ODA received (in %) in Singapore in 1987 to that in 1988?
Offer a terse response. 1.31. What is the ratio of the ODA received (in %) of Sub-Saharan Africa (developing only) in 1987 to that in 1989?
Give a very brief answer. 0.89. What is the ratio of the ODA received (in %) in Bahamas in 1987 to that in 1989?
Make the answer very short. 0.23. What is the ratio of the ODA received (in %) of Dominican Republic in 1987 to that in 1989?
Offer a very short reply. 1.04. What is the ratio of the ODA received (in %) in Singapore in 1987 to that in 1989?
Keep it short and to the point. 0.36. What is the ratio of the ODA received (in %) of Sub-Saharan Africa (developing only) in 1987 to that in 1990?
Offer a terse response. 0.77. What is the ratio of the ODA received (in %) of Bahamas in 1987 to that in 1990?
Give a very brief answer. 0.29. What is the ratio of the ODA received (in %) of Dominican Republic in 1987 to that in 1990?
Offer a terse response. 1.55. What is the ratio of the ODA received (in %) in Sub-Saharan Africa (developing only) in 1987 to that in 1991?
Your answer should be very brief. 0.81. What is the ratio of the ODA received (in %) of Bahamas in 1987 to that in 1991?
Offer a very short reply. 0.32. What is the ratio of the ODA received (in %) in Dominican Republic in 1987 to that in 1991?
Offer a terse response. 3.23. What is the ratio of the ODA received (in %) in Singapore in 1987 to that in 1991?
Ensure brevity in your answer.  6.59. What is the ratio of the ODA received (in %) in Sub-Saharan Africa (developing only) in 1988 to that in 1989?
Your answer should be compact. 0.96. What is the ratio of the ODA received (in %) of Bahamas in 1988 to that in 1989?
Make the answer very short. 1.26. What is the ratio of the ODA received (in %) in Dominican Republic in 1988 to that in 1989?
Offer a very short reply. 1.04. What is the ratio of the ODA received (in %) in Singapore in 1988 to that in 1989?
Your answer should be very brief. 0.28. What is the ratio of the ODA received (in %) of Sub-Saharan Africa (developing only) in 1988 to that in 1990?
Your response must be concise. 0.83. What is the ratio of the ODA received (in %) in Bahamas in 1988 to that in 1990?
Provide a succinct answer. 1.61. What is the ratio of the ODA received (in %) of Dominican Republic in 1988 to that in 1990?
Provide a succinct answer. 1.55. What is the ratio of the ODA received (in %) of Sub-Saharan Africa (developing only) in 1988 to that in 1991?
Your answer should be very brief. 0.87. What is the ratio of the ODA received (in %) of Bahamas in 1988 to that in 1991?
Ensure brevity in your answer.  1.81. What is the ratio of the ODA received (in %) of Dominican Republic in 1988 to that in 1991?
Offer a very short reply. 3.23. What is the ratio of the ODA received (in %) in Singapore in 1988 to that in 1991?
Your response must be concise. 5.05. What is the ratio of the ODA received (in %) in Sub-Saharan Africa (developing only) in 1989 to that in 1990?
Your response must be concise. 0.87. What is the ratio of the ODA received (in %) of Bahamas in 1989 to that in 1990?
Your response must be concise. 1.28. What is the ratio of the ODA received (in %) in Dominican Republic in 1989 to that in 1990?
Your answer should be very brief. 1.5. What is the ratio of the ODA received (in %) of Sub-Saharan Africa (developing only) in 1989 to that in 1991?
Provide a succinct answer. 0.9. What is the ratio of the ODA received (in %) in Bahamas in 1989 to that in 1991?
Your answer should be very brief. 1.43. What is the ratio of the ODA received (in %) in Dominican Republic in 1989 to that in 1991?
Provide a succinct answer. 3.11. What is the ratio of the ODA received (in %) in Singapore in 1989 to that in 1991?
Offer a terse response. 18.08. What is the ratio of the ODA received (in %) of Sub-Saharan Africa (developing only) in 1990 to that in 1991?
Your answer should be very brief. 1.04. What is the ratio of the ODA received (in %) of Bahamas in 1990 to that in 1991?
Your answer should be very brief. 1.12. What is the ratio of the ODA received (in %) in Dominican Republic in 1990 to that in 1991?
Ensure brevity in your answer.  2.08. What is the difference between the highest and the second highest ODA received (in %) in Sub-Saharan Africa (developing only)?
Make the answer very short. 0.24. What is the difference between the highest and the second highest ODA received (in %) in Bahamas?
Offer a very short reply. 0.37. What is the difference between the highest and the second highest ODA received (in %) in Dominican Republic?
Ensure brevity in your answer.  2.04. What is the difference between the highest and the second highest ODA received (in %) of Singapore?
Offer a terse response. 0.11. What is the difference between the highest and the lowest ODA received (in %) of Sub-Saharan Africa (developing only)?
Ensure brevity in your answer.  2.34. What is the difference between the highest and the lowest ODA received (in %) in Bahamas?
Provide a succinct answer. 0.58. What is the difference between the highest and the lowest ODA received (in %) of Dominican Republic?
Keep it short and to the point. 3.66. What is the difference between the highest and the lowest ODA received (in %) of Singapore?
Offer a terse response. 0.31. 